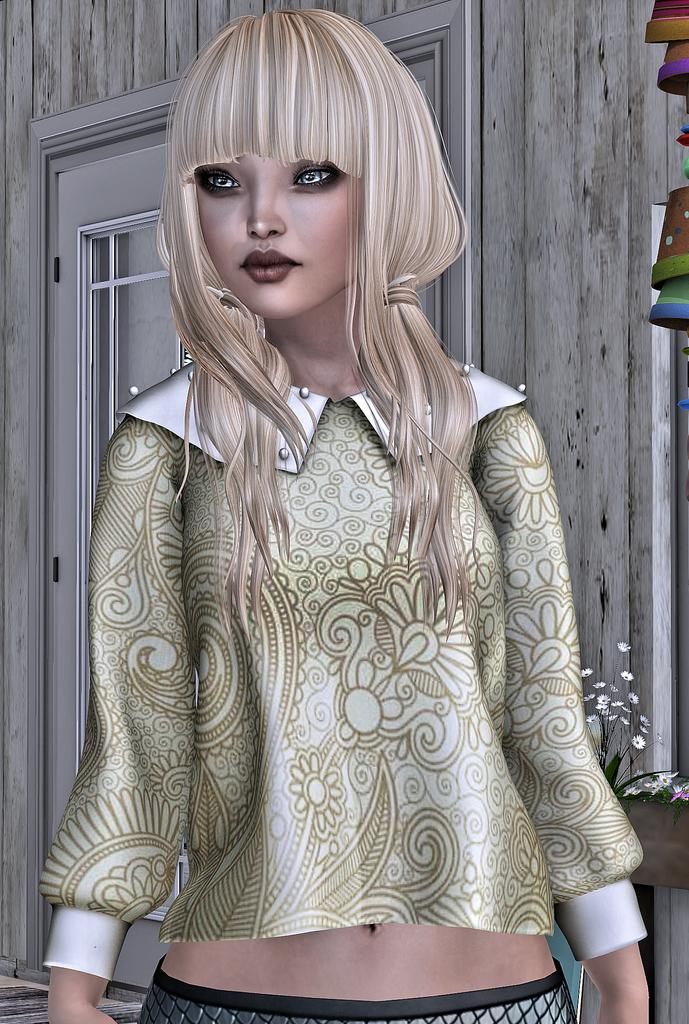What type of picture is in the image? The image contains an animated picture. Can you describe the person in the image? There is a person standing in the image, and they are wearing a brown and white shirt. What can be seen in the background of the image? There is a door visible in the background of the image, and the wall is gray. How much money does the person in the image have in their pocket? There is no information about the person's money in the image, so we cannot determine the amount. 